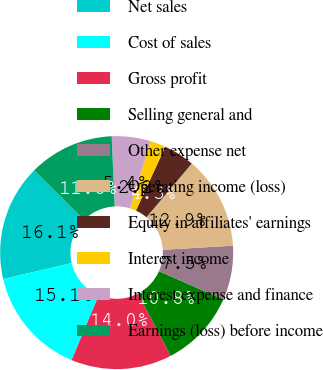Convert chart to OTSL. <chart><loc_0><loc_0><loc_500><loc_500><pie_chart><fcel>Net sales<fcel>Cost of sales<fcel>Gross profit<fcel>Selling general and<fcel>Other expense net<fcel>Operating income (loss)<fcel>Equity in affiliates' earnings<fcel>Interest income<fcel>Interest expense and finance<fcel>Earnings (loss) before income<nl><fcel>16.13%<fcel>15.05%<fcel>13.98%<fcel>10.75%<fcel>7.53%<fcel>12.9%<fcel>4.3%<fcel>2.15%<fcel>5.38%<fcel>11.83%<nl></chart> 